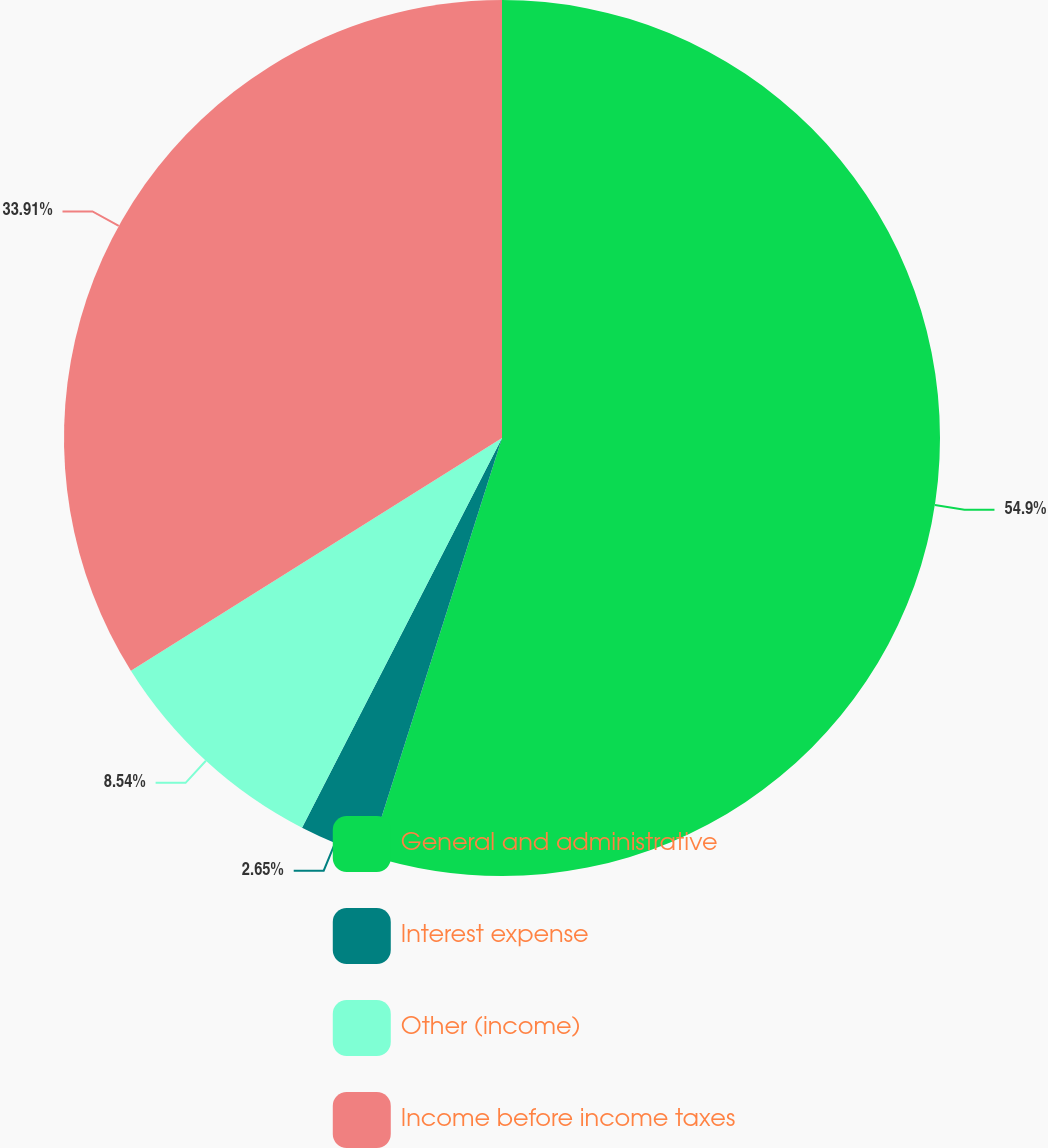Convert chart to OTSL. <chart><loc_0><loc_0><loc_500><loc_500><pie_chart><fcel>General and administrative<fcel>Interest expense<fcel>Other (income)<fcel>Income before income taxes<nl><fcel>54.89%<fcel>2.65%<fcel>8.54%<fcel>33.91%<nl></chart> 